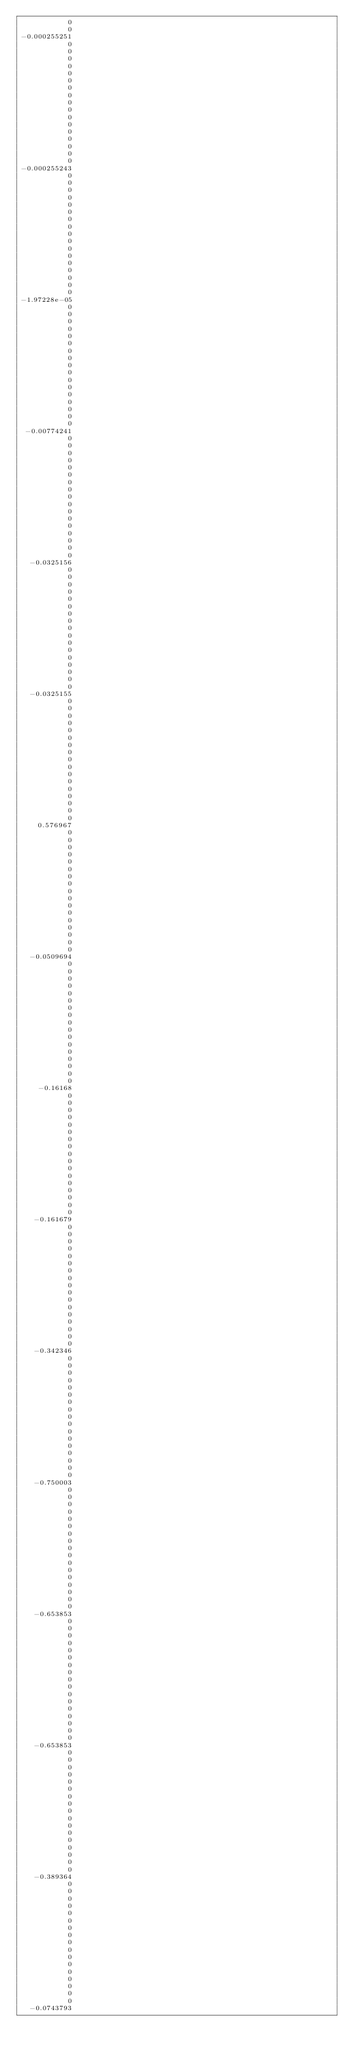Convert code to text. <code><loc_0><loc_0><loc_500><loc_500><_ObjectiveC_>           0
           0
-0.000255251
           0
           0
           0
           0
           0
           0
           0
           0
           0
           0
           0
           0
           0
           0
           0
           0
           0
-0.000255243
           0
           0
           0
           0
           0
           0
           0
           0
           0
           0
           0
           0
           0
           0
           0
           0
           0
-1.97228e-05
           0
           0
           0
           0
           0
           0
           0
           0
           0
           0
           0
           0
           0
           0
           0
           0
           0
 -0.00774241
           0
           0
           0
           0
           0
           0
           0
           0
           0
           0
           0
           0
           0
           0
           0
           0
           0
  -0.0325156
           0
           0
           0
           0
           0
           0
           0
           0
           0
           0
           0
           0
           0
           0
           0
           0
           0
  -0.0325155
           0
           0
           0
           0
           0
           0
           0
           0
           0
           0
           0
           0
           0
           0
           0
           0
           0
    0.576967
           0
           0
           0
           0
           0
           0
           0
           0
           0
           0
           0
           0
           0
           0
           0
           0
           0
  -0.0509694
           0
           0
           0
           0
           0
           0
           0
           0
           0
           0
           0
           0
           0
           0
           0
           0
           0
    -0.16168
           0
           0
           0
           0
           0
           0
           0
           0
           0
           0
           0
           0
           0
           0
           0
           0
           0
   -0.161679
           0
           0
           0
           0
           0
           0
           0
           0
           0
           0
           0
           0
           0
           0
           0
           0
           0
   -0.342346
           0
           0
           0
           0
           0
           0
           0
           0
           0
           0
           0
           0
           0
           0
           0
           0
           0
   -0.750003
           0
           0
           0
           0
           0
           0
           0
           0
           0
           0
           0
           0
           0
           0
           0
           0
           0
   -0.653853
           0
           0
           0
           0
           0
           0
           0
           0
           0
           0
           0
           0
           0
           0
           0
           0
           0
   -0.653853
           0
           0
           0
           0
           0
           0
           0
           0
           0
           0
           0
           0
           0
           0
           0
           0
           0
   -0.389364
           0
           0
           0
           0
           0
           0
           0
           0
           0
           0
           0
           0
           0
           0
           0
           0
           0
  -0.0743793</code> 